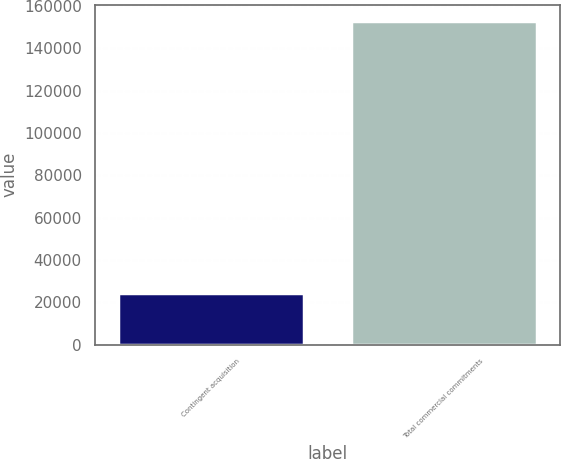Convert chart to OTSL. <chart><loc_0><loc_0><loc_500><loc_500><bar_chart><fcel>Contingent acquisition<fcel>Total commercial commitments<nl><fcel>24165<fcel>153007<nl></chart> 